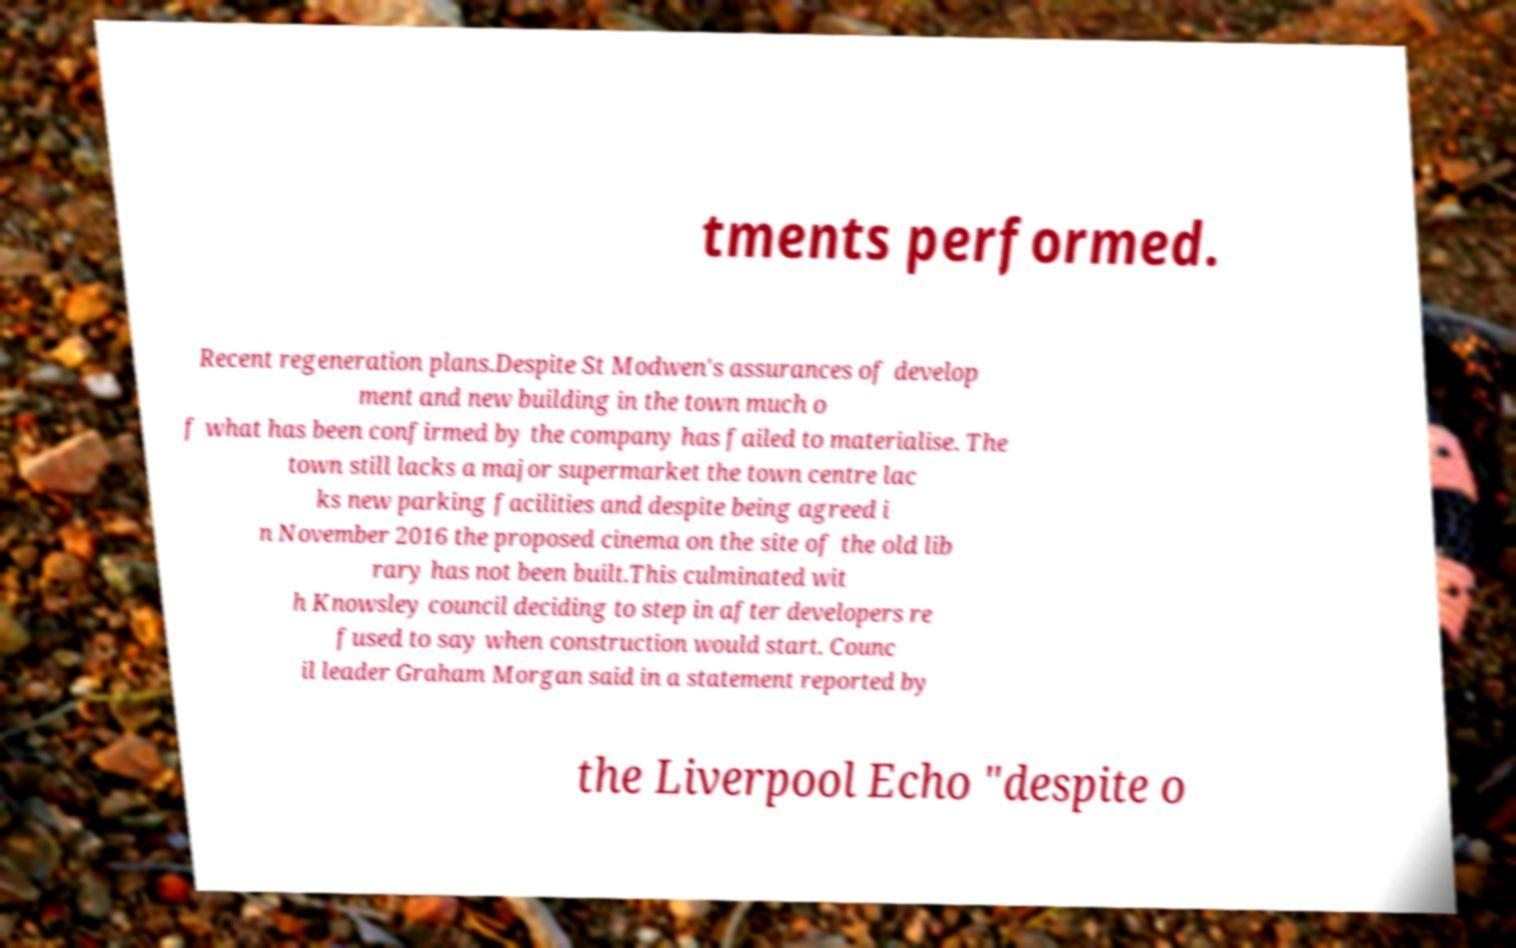There's text embedded in this image that I need extracted. Can you transcribe it verbatim? tments performed. Recent regeneration plans.Despite St Modwen's assurances of develop ment and new building in the town much o f what has been confirmed by the company has failed to materialise. The town still lacks a major supermarket the town centre lac ks new parking facilities and despite being agreed i n November 2016 the proposed cinema on the site of the old lib rary has not been built.This culminated wit h Knowsley council deciding to step in after developers re fused to say when construction would start. Counc il leader Graham Morgan said in a statement reported by the Liverpool Echo "despite o 